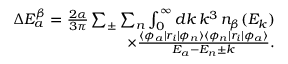Convert formula to latex. <formula><loc_0><loc_0><loc_500><loc_500>\begin{array} { r } { \Delta E _ { a } ^ { \beta } = \frac { 2 \alpha } { 3 \pi } \sum _ { \pm } \sum _ { n } \int _ { 0 } ^ { \infty } d k \, k ^ { 3 } \, n _ { \beta } ( E _ { k } ) } \\ { \times \frac { \langle \phi _ { a } | r _ { i } | \phi _ { n } \rangle \langle \phi _ { n } | r _ { i } | \phi _ { a } \rangle } { E _ { a } - E _ { n } \pm k } . } \end{array}</formula> 